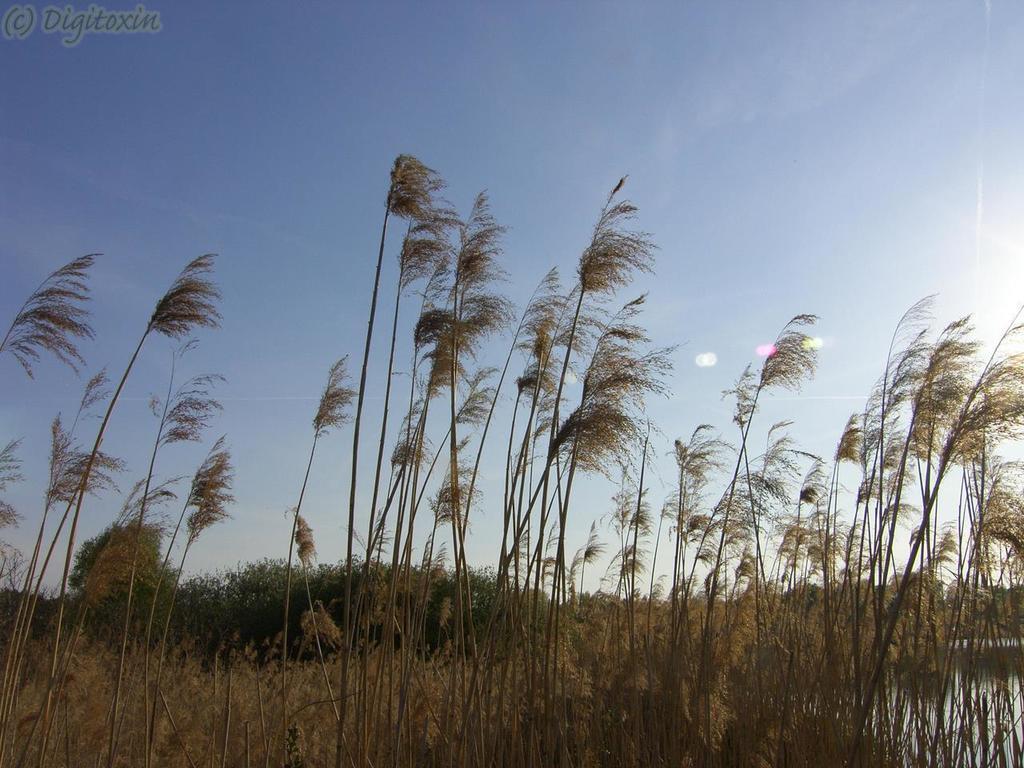How would you summarize this image in a sentence or two? In the image we can see the plants, grass, water and the pale blue sky. On the top left, we can see watermark. 